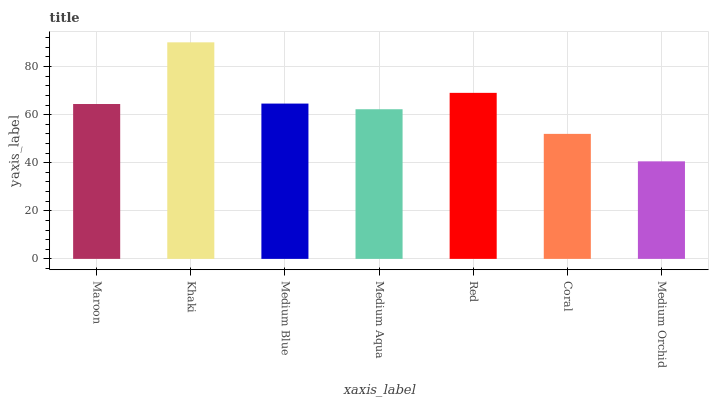Is Medium Blue the minimum?
Answer yes or no. No. Is Medium Blue the maximum?
Answer yes or no. No. Is Khaki greater than Medium Blue?
Answer yes or no. Yes. Is Medium Blue less than Khaki?
Answer yes or no. Yes. Is Medium Blue greater than Khaki?
Answer yes or no. No. Is Khaki less than Medium Blue?
Answer yes or no. No. Is Maroon the high median?
Answer yes or no. Yes. Is Maroon the low median?
Answer yes or no. Yes. Is Coral the high median?
Answer yes or no. No. Is Medium Orchid the low median?
Answer yes or no. No. 